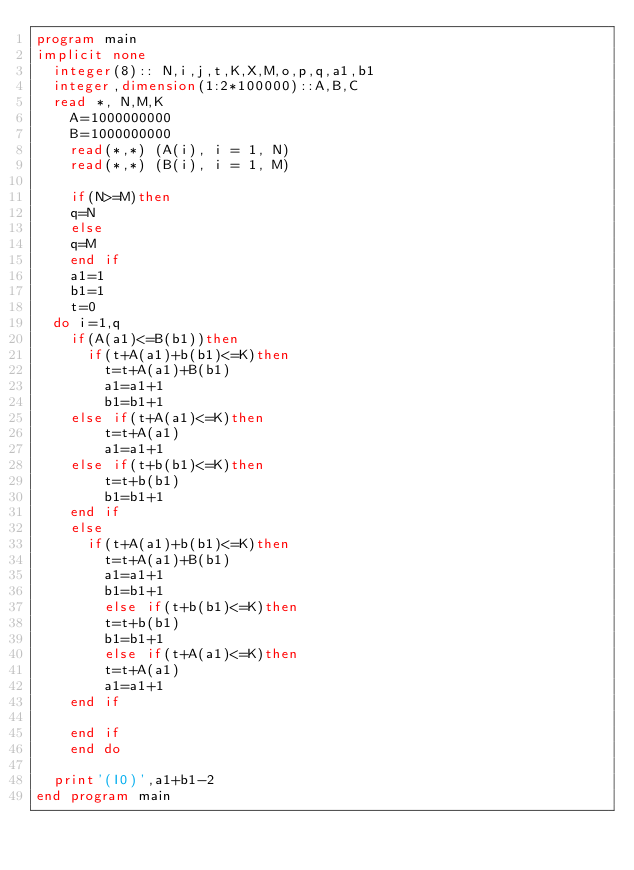Convert code to text. <code><loc_0><loc_0><loc_500><loc_500><_FORTRAN_>program main
implicit none
	integer(8):: N,i,j,t,K,X,M,o,p,q,a1,b1
	integer,dimension(1:2*100000)::A,B,C
	read *, N,M,K
    A=1000000000
    B=1000000000
    read(*,*) (A(i), i = 1, N)
    read(*,*) (B(i), i = 1, M)

   	if(N>=M)then
    q=N
    else
    q=M
    end if
    a1=1
    b1=1
    t=0
	do i=1,q
    if(A(a1)<=B(b1))then
    	if(t+A(a1)+b(b1)<=K)then
        t=t+A(a1)+B(b1)
        a1=a1+1
        b1=b1+1
		else if(t+A(a1)<=K)then
        t=t+A(a1)
        a1=a1+1
		else if(t+b(b1)<=K)then
        t=t+b(b1)
        b1=b1+1
		end if
    else
    	if(t+A(a1)+b(b1)<=K)then
        t=t+A(a1)+B(b1)
        a1=a1+1
        b1=b1+1
        else if(t+b(b1)<=K)then
        t=t+b(b1)
        b1=b1+1
        else if(t+A(a1)<=K)then
        t=t+A(a1)
        a1=a1+1
		end if

    end if
    end do
    
 	print'(I0)',a1+b1-2
end program main

</code> 